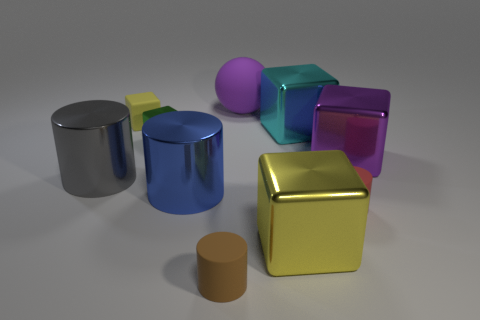Subtract all rubber blocks. How many blocks are left? 4 Subtract all purple cubes. How many cubes are left? 4 Subtract all green cylinders. Subtract all yellow blocks. How many cylinders are left? 4 Subtract all balls. How many objects are left? 9 Subtract 0 green spheres. How many objects are left? 10 Subtract all big blue metallic cylinders. Subtract all large purple spheres. How many objects are left? 8 Add 7 green metal blocks. How many green metal blocks are left? 8 Add 10 large blue rubber objects. How many large blue rubber objects exist? 10 